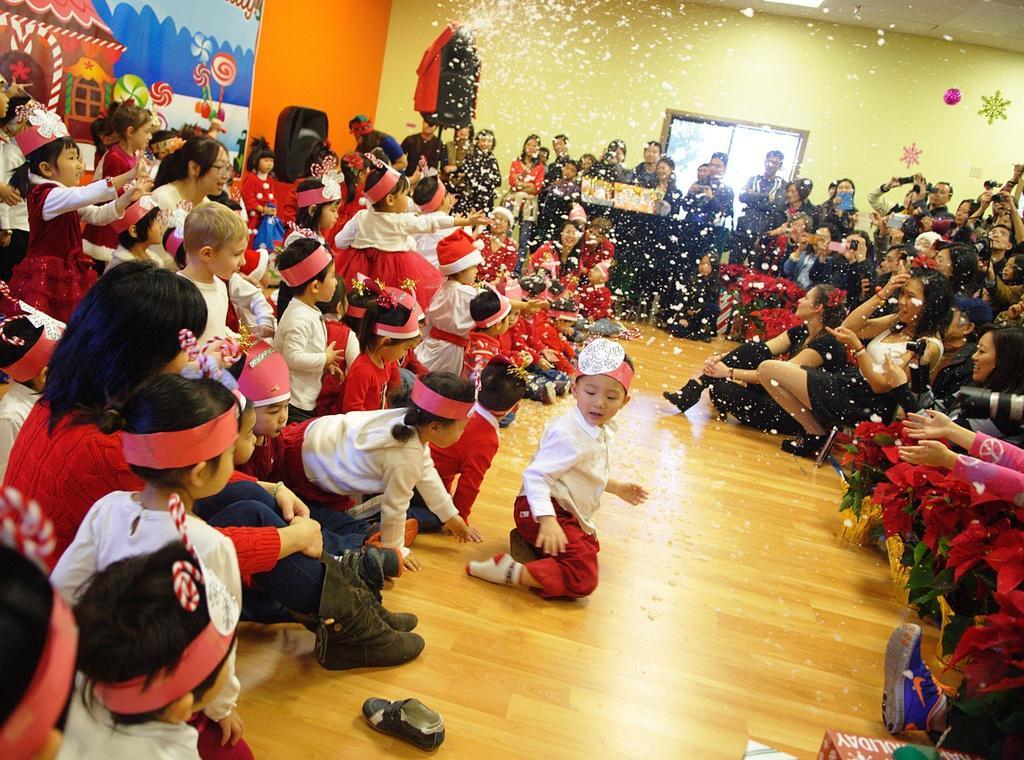Could you give a brief overview of what you see in this image? This is an inside view of a room. Here I can see many people. It seems like these people are celebrating an event. On the left side there are children. On the the right side many people are looking at the children. In the background there is a wall and window. 